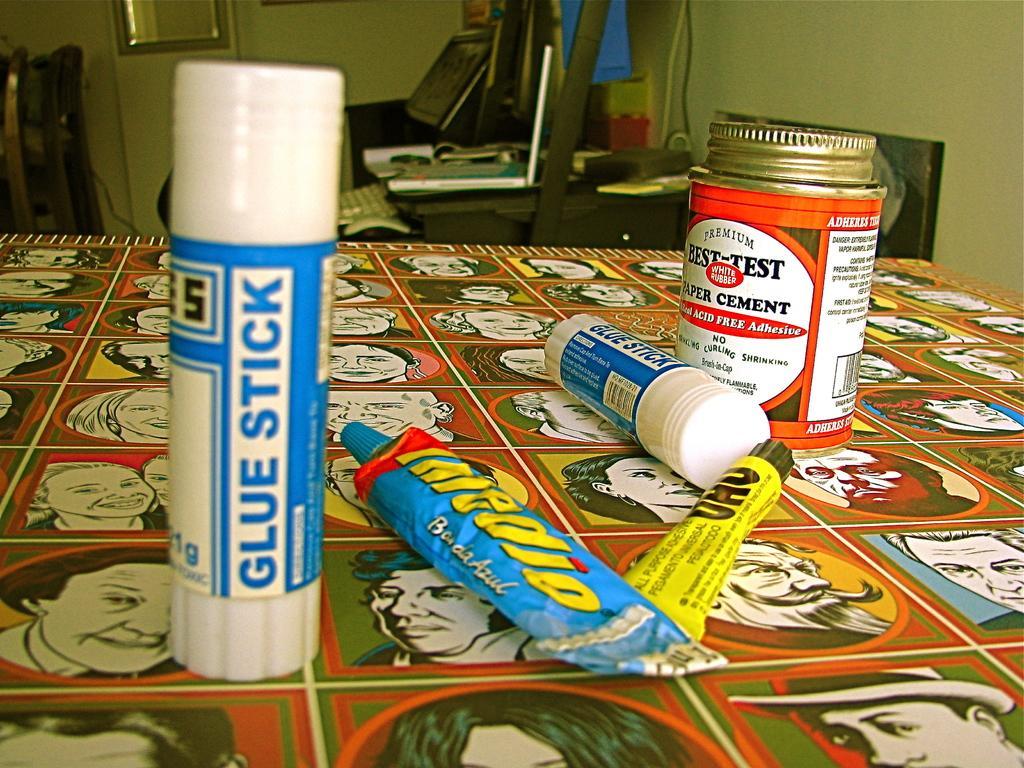Can you describe this image briefly? On this poster there are images of people. Above this poster there are glue sticks, tubs and container. Far there is a table. Above the table there is a laptop, keyboard and things. 